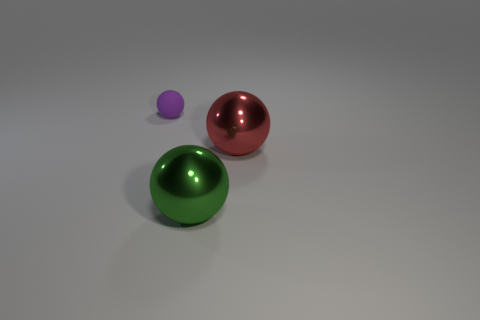Is the number of big metallic things in front of the red metal object the same as the number of small purple rubber balls behind the matte sphere?
Keep it short and to the point. No. There is another metal object that is the same shape as the large red object; what is its color?
Your response must be concise. Green. What shape is the metal object that is right of the ball that is in front of the ball that is to the right of the large green metallic object?
Provide a short and direct response. Sphere. The purple object is what size?
Give a very brief answer. Small. What color is the other big sphere that is the same material as the big green ball?
Offer a very short reply. Red. What number of other small purple objects are made of the same material as the tiny purple thing?
Offer a very short reply. 0. What is the color of the object that is on the left side of the large object that is to the left of the big red thing?
Provide a short and direct response. Purple. What is the color of the other metallic sphere that is the same size as the red sphere?
Give a very brief answer. Green. Are there any big brown metal things that have the same shape as the small purple thing?
Offer a terse response. No. What shape is the small object?
Ensure brevity in your answer.  Sphere. 